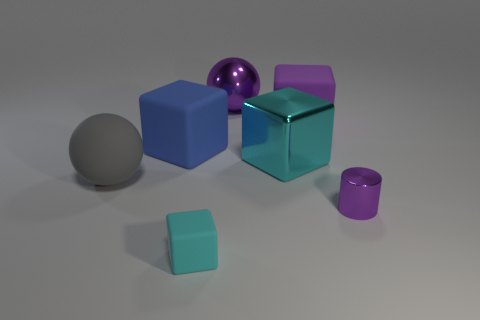Is there anything else that has the same shape as the small purple metallic thing?
Offer a very short reply. No. There is a large object that is the same color as the metal sphere; what is its shape?
Give a very brief answer. Cube. Are there any other things that have the same color as the large rubber sphere?
Your answer should be compact. No. The big block to the left of the matte block in front of the cyan block that is right of the large purple metallic object is made of what material?
Your answer should be compact. Rubber. What number of rubber objects are either purple cylinders or balls?
Give a very brief answer. 1. Does the small cylinder have the same color as the metal ball?
Ensure brevity in your answer.  Yes. How many objects are large rubber things or purple cylinders in front of the large blue matte cube?
Ensure brevity in your answer.  4. There is a cyan thing in front of the cylinder; does it have the same size as the metallic cylinder?
Keep it short and to the point. Yes. How many other things are there of the same shape as the tiny cyan object?
Provide a short and direct response. 3. How many brown objects are small metallic cylinders or matte things?
Your response must be concise. 0. 